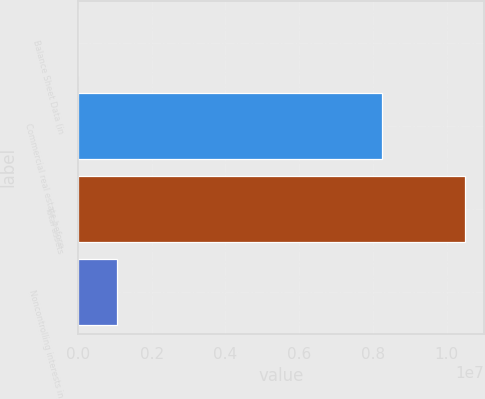Convert chart. <chart><loc_0><loc_0><loc_500><loc_500><bar_chart><fcel>Balance Sheet Data (in<fcel>Commercial real estate before<fcel>Total assets<fcel>Noncontrolling interests in<nl><fcel>2009<fcel>8.2571e+06<fcel>1.04876e+07<fcel>1.05057e+06<nl></chart> 